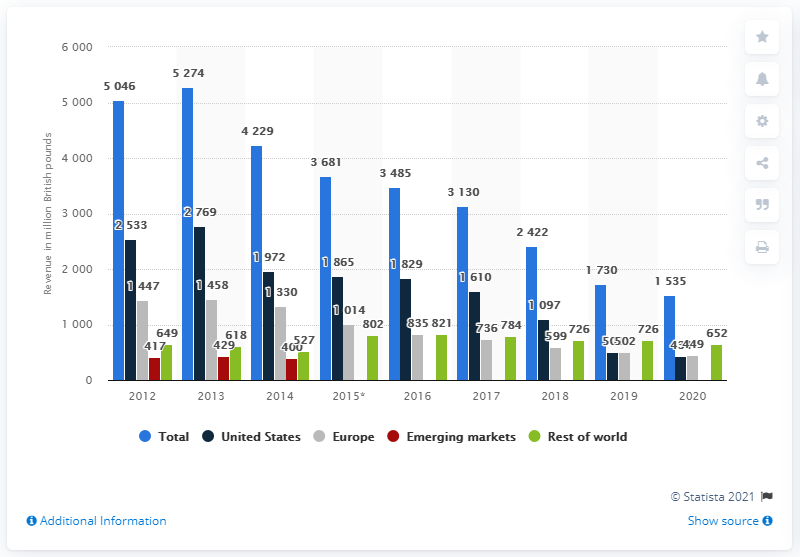Draw attention to some important aspects in this diagram. In the United States in 2020, the revenue generated by Seretide/Advair was approximately 434 million US dollars. 